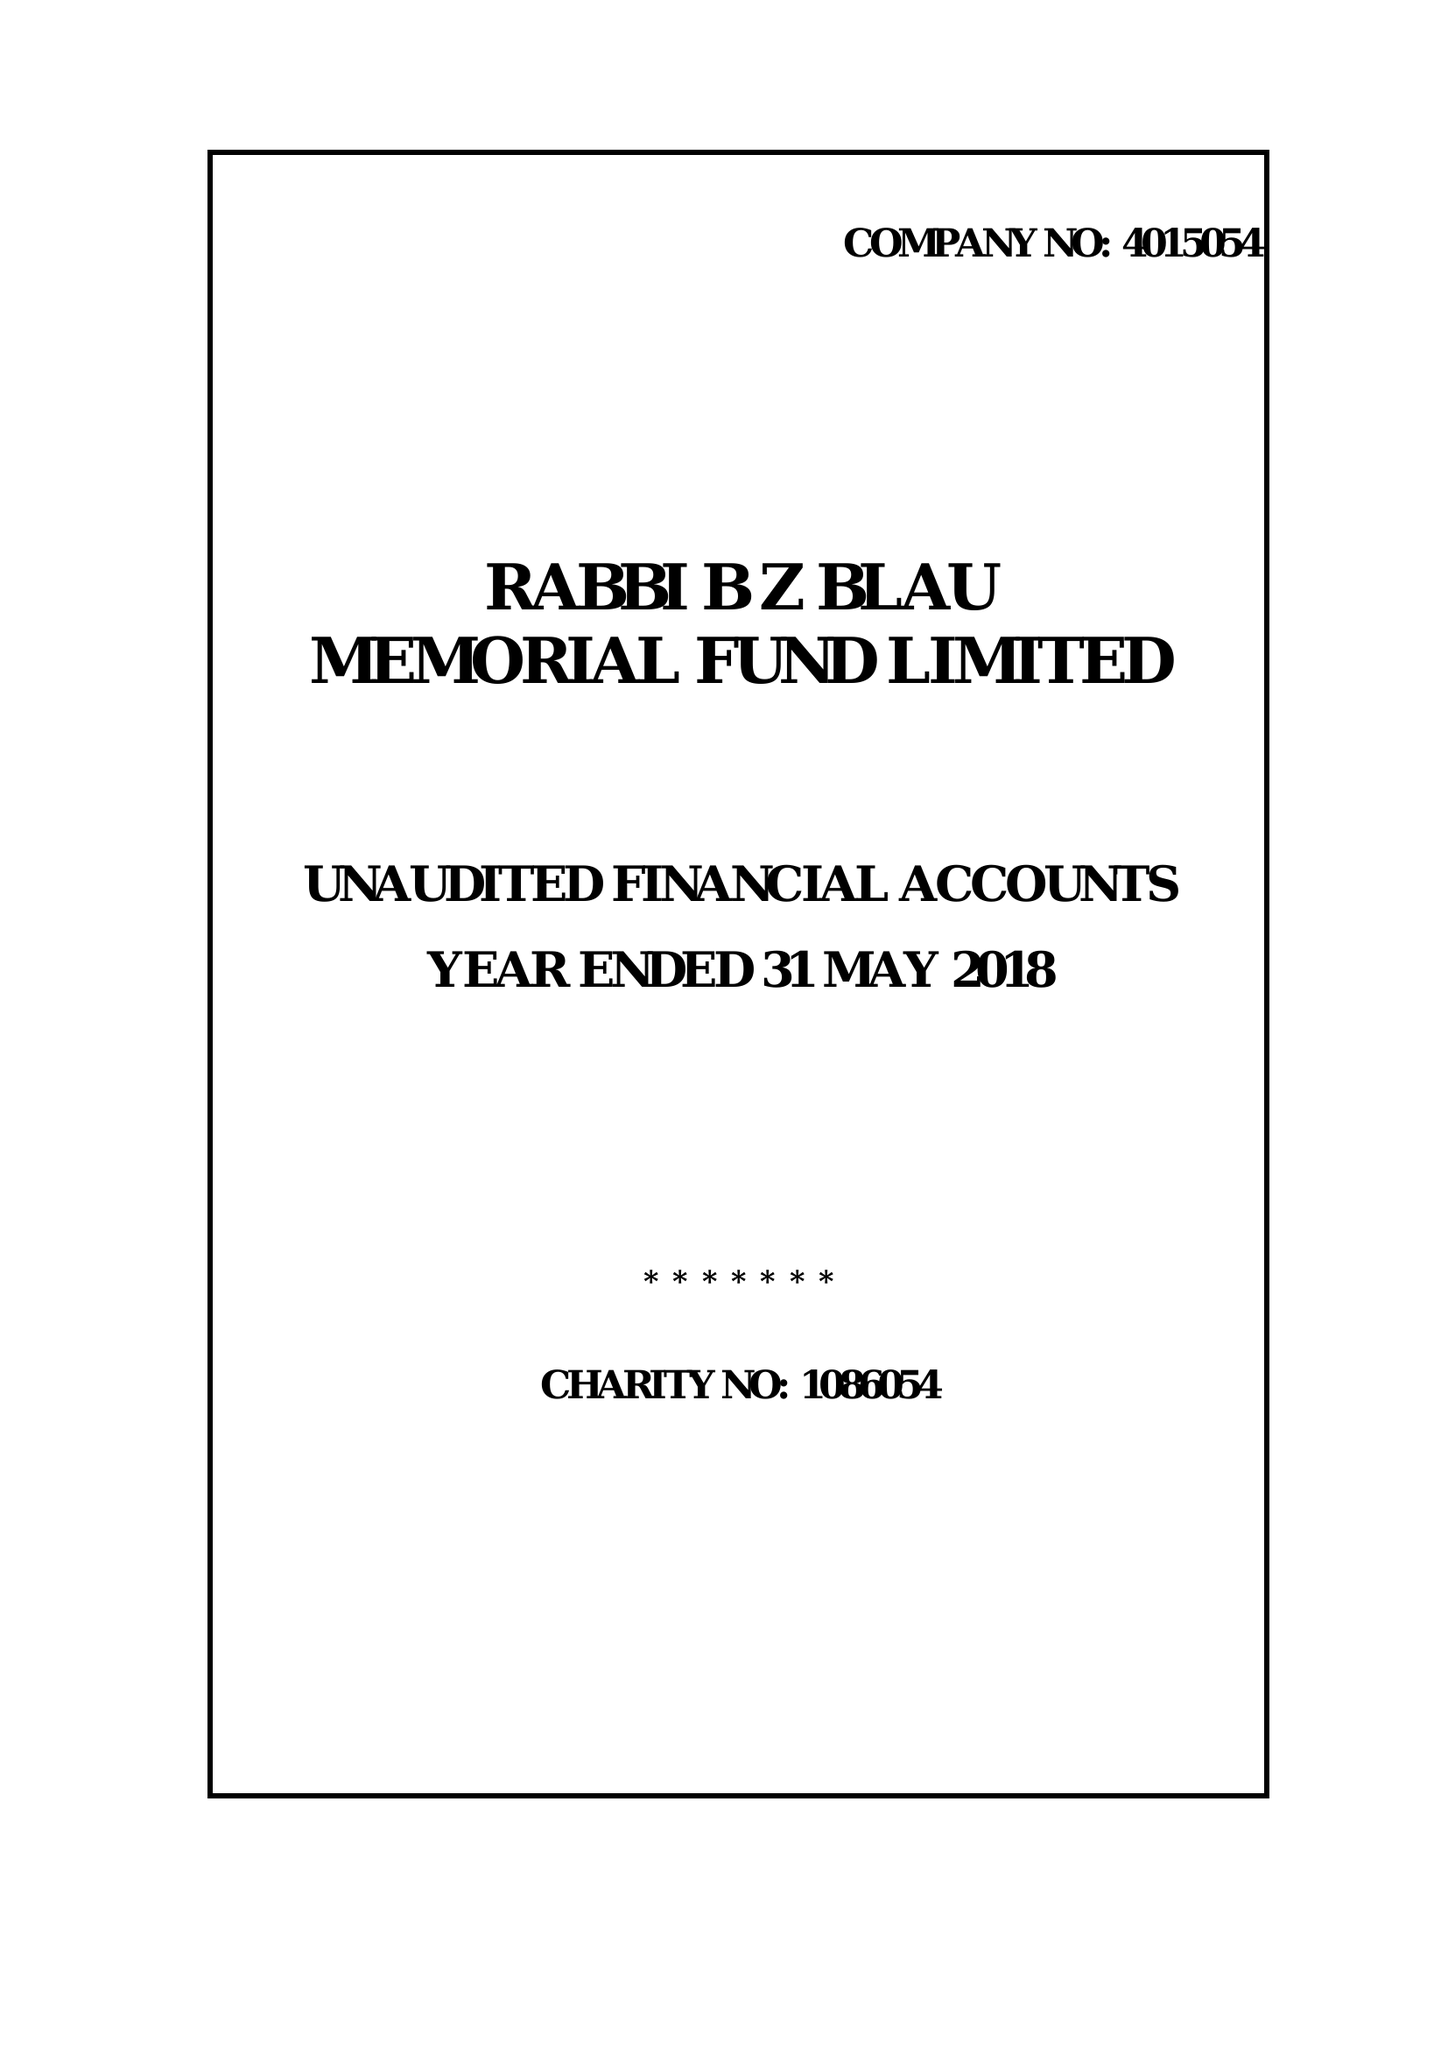What is the value for the income_annually_in_british_pounds?
Answer the question using a single word or phrase. 34916.00 